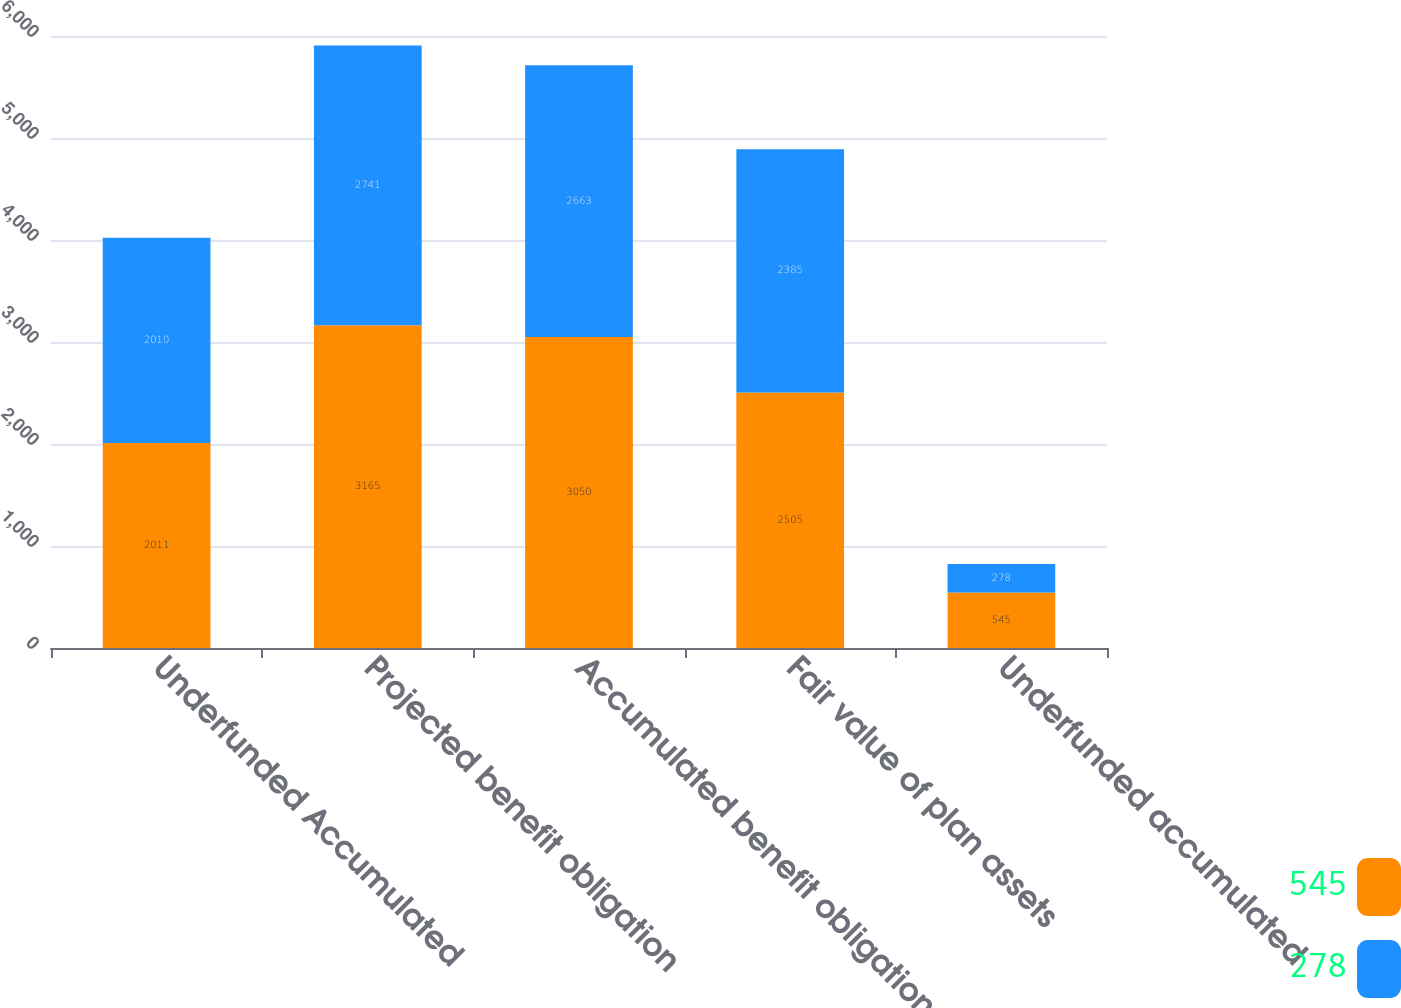<chart> <loc_0><loc_0><loc_500><loc_500><stacked_bar_chart><ecel><fcel>Underfunded Accumulated<fcel>Projected benefit obligation<fcel>Accumulated benefit obligation<fcel>Fair value of plan assets<fcel>Underfunded accumulated<nl><fcel>545<fcel>2011<fcel>3165<fcel>3050<fcel>2505<fcel>545<nl><fcel>278<fcel>2010<fcel>2741<fcel>2663<fcel>2385<fcel>278<nl></chart> 